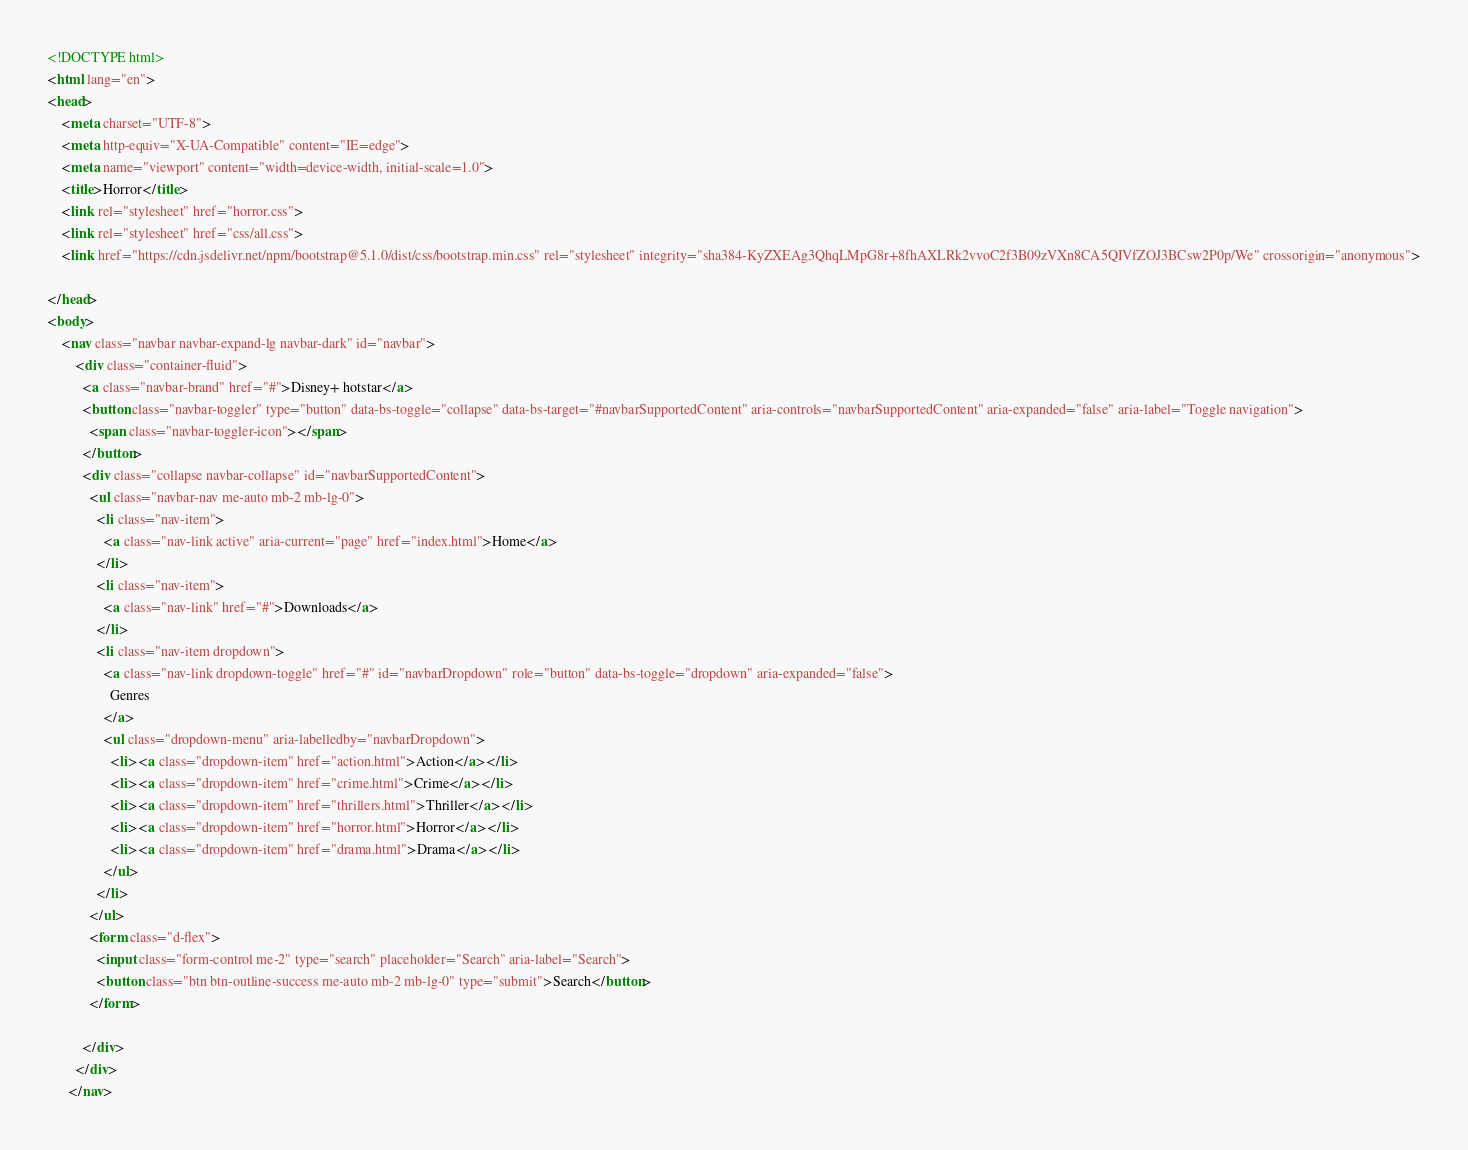<code> <loc_0><loc_0><loc_500><loc_500><_HTML_><!DOCTYPE html>
<html lang="en">
<head>
    <meta charset="UTF-8">
    <meta http-equiv="X-UA-Compatible" content="IE=edge">
    <meta name="viewport" content="width=device-width, initial-scale=1.0">
    <title>Horror</title>
    <link rel="stylesheet" href="horror.css">
    <link rel="stylesheet" href="css/all.css">
    <link href="https://cdn.jsdelivr.net/npm/bootstrap@5.1.0/dist/css/bootstrap.min.css" rel="stylesheet" integrity="sha384-KyZXEAg3QhqLMpG8r+8fhAXLRk2vvoC2f3B09zVXn8CA5QIVfZOJ3BCsw2P0p/We" crossorigin="anonymous">
    
</head>
<body>
    <nav class="navbar navbar-expand-lg navbar-dark" id="navbar">
        <div class="container-fluid">
          <a class="navbar-brand" href="#">Disney+ hotstar</a>
          <button class="navbar-toggler" type="button" data-bs-toggle="collapse" data-bs-target="#navbarSupportedContent" aria-controls="navbarSupportedContent" aria-expanded="false" aria-label="Toggle navigation">
            <span class="navbar-toggler-icon"></span>
          </button>
          <div class="collapse navbar-collapse" id="navbarSupportedContent">
            <ul class="navbar-nav me-auto mb-2 mb-lg-0">
              <li class="nav-item">
                <a class="nav-link active" aria-current="page" href="index.html">Home</a>
              </li>
              <li class="nav-item">
                <a class="nav-link" href="#">Downloads</a>
              </li>
              <li class="nav-item dropdown">
                <a class="nav-link dropdown-toggle" href="#" id="navbarDropdown" role="button" data-bs-toggle="dropdown" aria-expanded="false">
                  Genres
                </a>
                <ul class="dropdown-menu" aria-labelledby="navbarDropdown">
                  <li><a class="dropdown-item" href="action.html">Action</a></li>
                  <li><a class="dropdown-item" href="crime.html">Crime</a></li>
                  <li><a class="dropdown-item" href="thrillers.html">Thriller</a></li>
                  <li><a class="dropdown-item" href="horror.html">Horror</a></li>
                  <li><a class="dropdown-item" href="drama.html">Drama</a></li>
                </ul>
              </li>
            </ul>
            <form class="d-flex">
              <input class="form-control me-2" type="search" placeholder="Search" aria-label="Search">
              <button class="btn btn-outline-success me-auto mb-2 mb-lg-0" type="submit">Search</button>
            </form>
           
          </div>
        </div>
      </nav></code> 